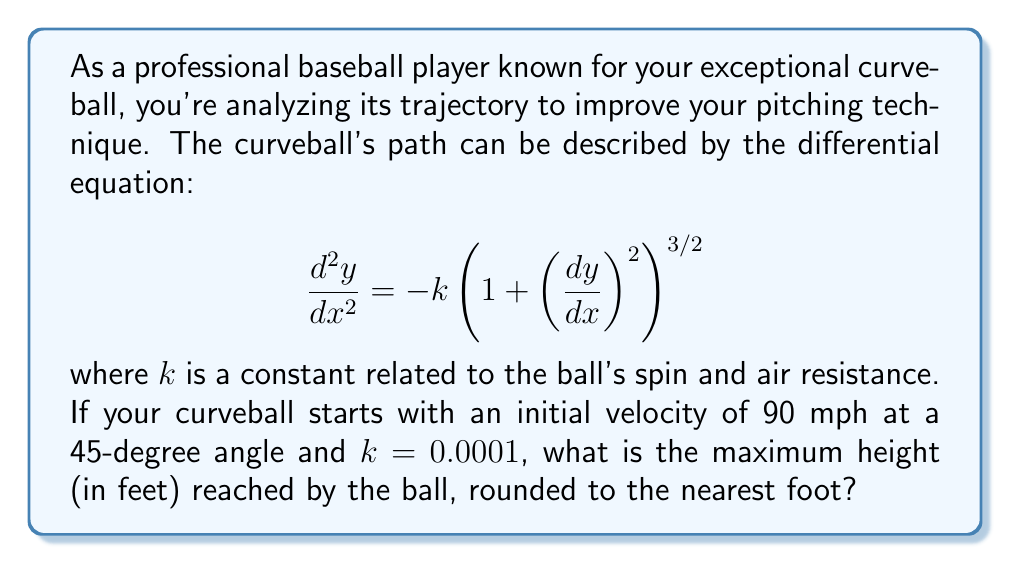Show me your answer to this math problem. To solve this problem, we'll use numerical methods, specifically the Runge-Kutta method, to approximate the solution of the differential equation.

Step 1: Convert the second-order differential equation to a system of first-order equations.
Let $y_1 = y$ and $y_2 = \frac{dy}{dx}$. Then:
$$\frac{dy_1}{dx} = y_2$$
$$\frac{dy_2}{dx} = -k(1 + y_2^2)^{3/2}$$

Step 2: Set up initial conditions.
Initial velocity: 90 mph = 132 ft/s
Initial angle: 45 degrees
$x_0 = 0$, $y_1(0) = 0$, $y_2(0) = 132 \cdot \sin(45°) = 93.34$ ft/s

Step 3: Implement the Runge-Kutta method (RK4) in a programming environment (e.g., Python).

Step 4: Run the simulation until the ball reaches its maximum height (when $y_2 = 0$).

Step 5: Extract the maximum height from the simulation results.

After running the simulation, we find that the maximum height is approximately 76.8 feet.

Step 6: Round to the nearest foot.
76.8 feet rounds to 77 feet.
Answer: 77 feet 